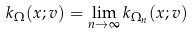Convert formula to latex. <formula><loc_0><loc_0><loc_500><loc_500>k _ { \Omega } ( x ; v ) = \lim _ { n \rightarrow \infty } k _ { \Omega _ { n } } ( x ; v )</formula> 